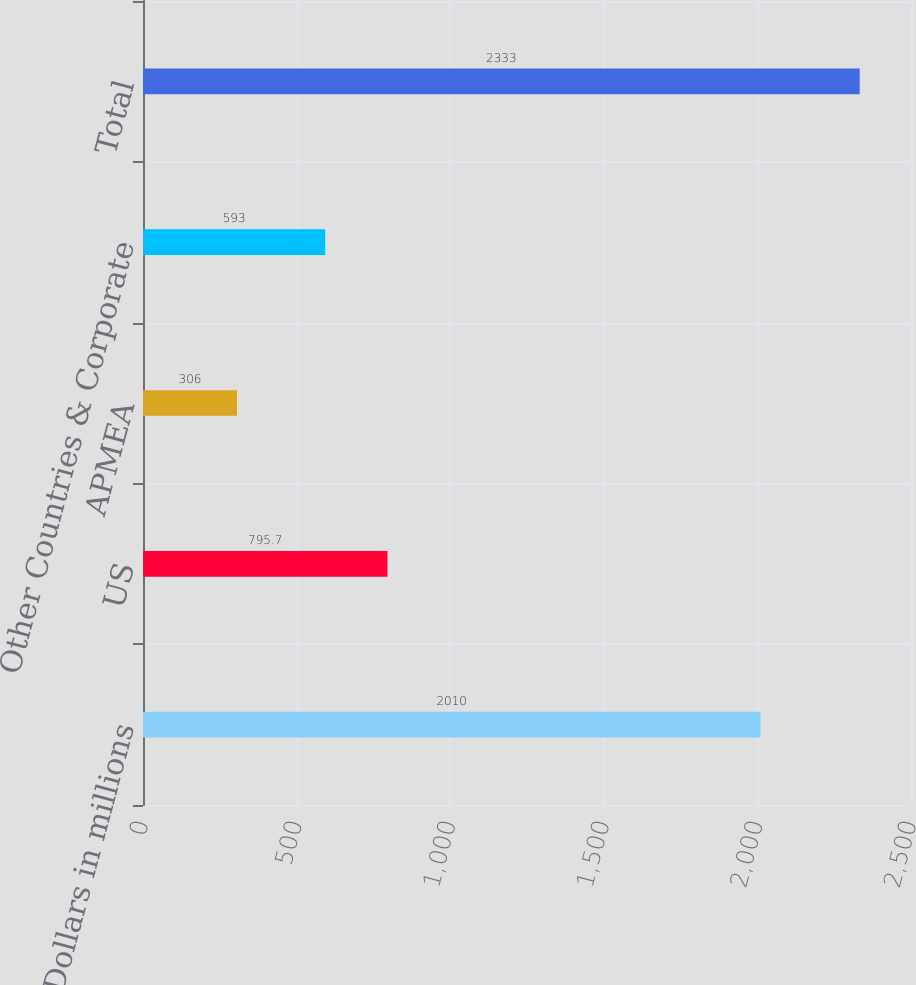<chart> <loc_0><loc_0><loc_500><loc_500><bar_chart><fcel>Dollars in millions<fcel>US<fcel>APMEA<fcel>Other Countries & Corporate<fcel>Total<nl><fcel>2010<fcel>795.7<fcel>306<fcel>593<fcel>2333<nl></chart> 